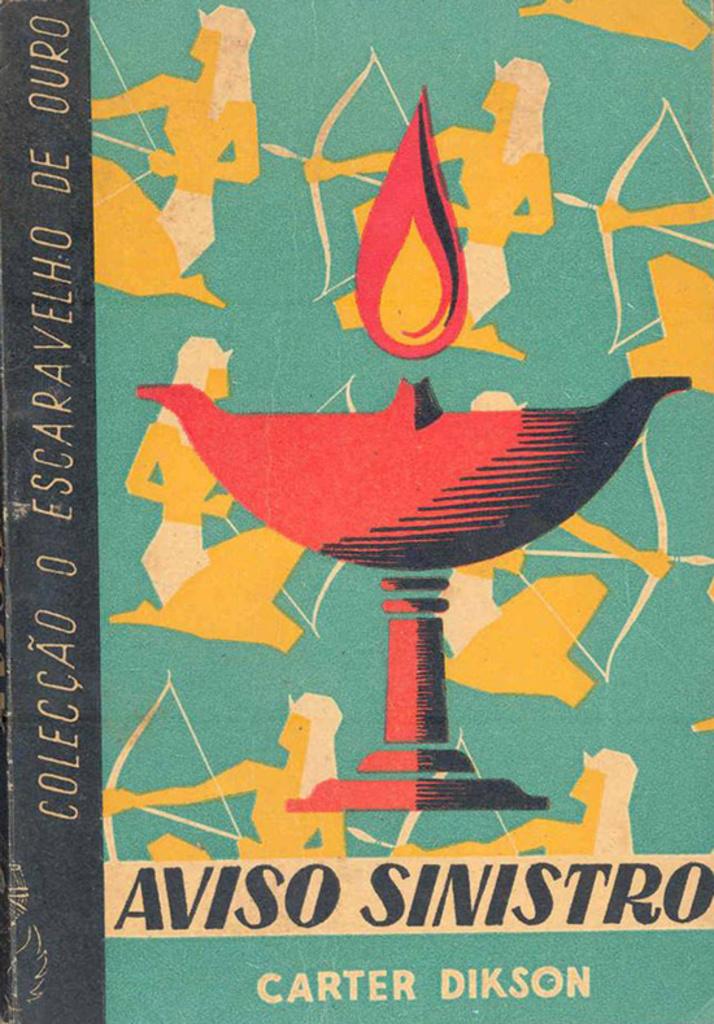Who is the author of this book?
Keep it short and to the point. Carter dikson. What is the title of the book?
Offer a terse response. Aviso sinistro. 